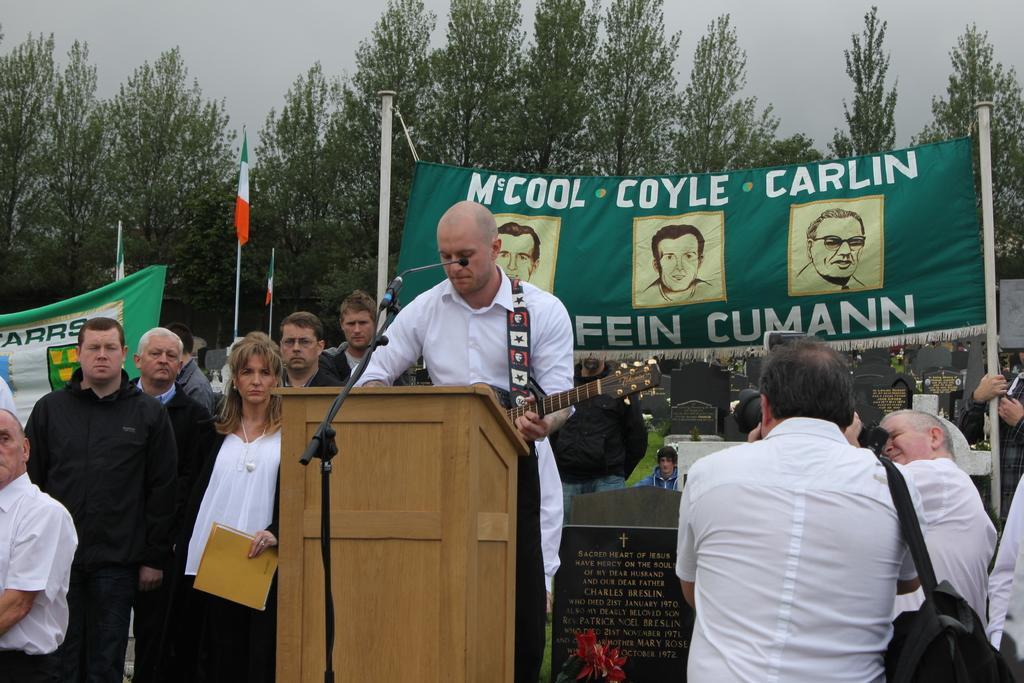Could you give a brief overview of what you see in this image? This image consists of persons standing. The man in the center is standing and in front of the man there is a podium and a mic. In the front on the right side there are persons standing and clicking a photo. On the left side there is a woman holding a file. In the background there are banners with some text written on it and there are trees, flags, and the sky is cloudy. 